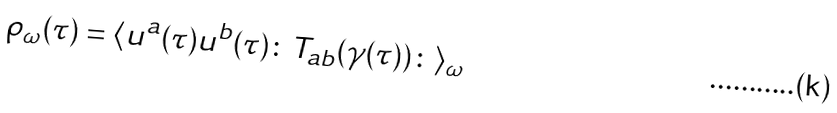<formula> <loc_0><loc_0><loc_500><loc_500>\rho _ { \omega } ( \tau ) = \langle u ^ { a } ( \tau ) u ^ { b } ( \tau ) \colon T _ { a b } ( \gamma ( \tau ) ) \colon \rangle _ { \omega }</formula> 